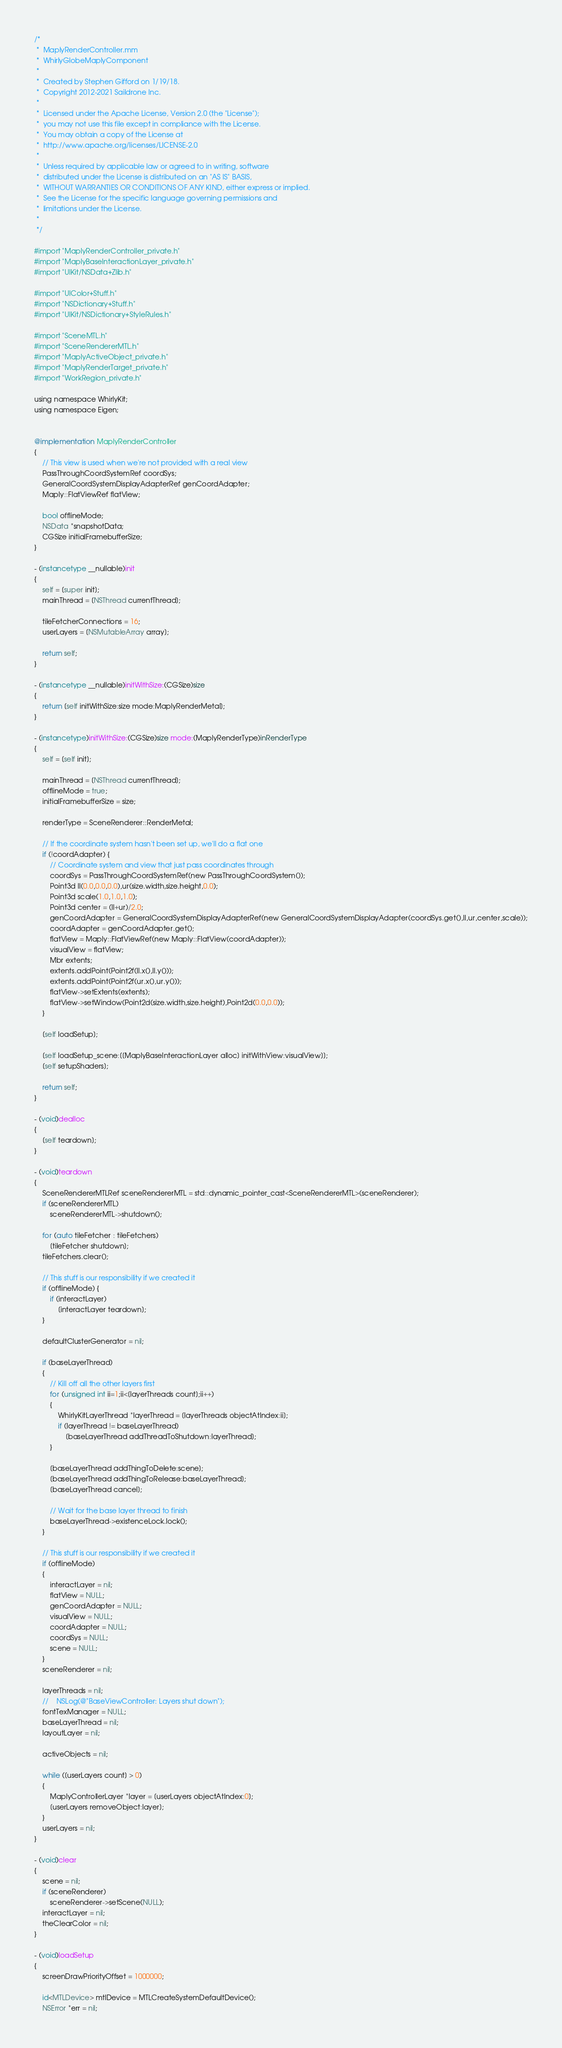<code> <loc_0><loc_0><loc_500><loc_500><_ObjectiveC_>/*
 *  MaplyRenderController.mm
 *  WhirlyGlobeMaplyComponent
 *
 *  Created by Stephen Gifford on 1/19/18.
 *  Copyright 2012-2021 Saildrone Inc.
 *
 *  Licensed under the Apache License, Version 2.0 (the "License");
 *  you may not use this file except in compliance with the License.
 *  You may obtain a copy of the License at
 *  http://www.apache.org/licenses/LICENSE-2.0
 *
 *  Unless required by applicable law or agreed to in writing, software
 *  distributed under the License is distributed on an "AS IS" BASIS,
 *  WITHOUT WARRANTIES OR CONDITIONS OF ANY KIND, either express or implied.
 *  See the License for the specific language governing permissions and
 *  limitations under the License.
 *
 */

#import "MaplyRenderController_private.h"
#import "MaplyBaseInteractionLayer_private.h"
#import "UIKit/NSData+Zlib.h"

#import "UIColor+Stuff.h"
#import "NSDictionary+Stuff.h"
#import "UIKit/NSDictionary+StyleRules.h"

#import "SceneMTL.h"
#import "SceneRendererMTL.h"
#import "MaplyActiveObject_private.h"
#import "MaplyRenderTarget_private.h"
#import "WorkRegion_private.h"

using namespace WhirlyKit;
using namespace Eigen;


@implementation MaplyRenderController
{
    // This view is used when we're not provided with a real view
    PassThroughCoordSystemRef coordSys;
    GeneralCoordSystemDisplayAdapterRef genCoordAdapter;
    Maply::FlatViewRef flatView;

    bool offlineMode;
    NSData *snapshotData;
    CGSize initialFramebufferSize;
}

- (instancetype __nullable)init
{
    self = [super init];
    mainThread = [NSThread currentThread];

    tileFetcherConnections = 16;
    userLayers = [NSMutableArray array];

    return self;
}

- (instancetype __nullable)initWithSize:(CGSize)size
{
    return [self initWithSize:size mode:MaplyRenderMetal];
}

- (instancetype)initWithSize:(CGSize)size mode:(MaplyRenderType)inRenderType
{
    self = [self init];

    mainThread = [NSThread currentThread];
    offlineMode = true;
    initialFramebufferSize = size;
    
    renderType = SceneRenderer::RenderMetal;
    
    // If the coordinate system hasn't been set up, we'll do a flat one
    if (!coordAdapter) {
        // Coordinate system and view that just pass coordinates through
        coordSys = PassThroughCoordSystemRef(new PassThroughCoordSystem());
        Point3d ll(0.0,0.0,0.0),ur(size.width,size.height,0.0);
        Point3d scale(1.0,1.0,1.0);
        Point3d center = (ll+ur)/2.0;
        genCoordAdapter = GeneralCoordSystemDisplayAdapterRef(new GeneralCoordSystemDisplayAdapter(coordSys.get(),ll,ur,center,scale));
        coordAdapter = genCoordAdapter.get();
        flatView = Maply::FlatViewRef(new Maply::FlatView(coordAdapter));
        visualView = flatView;
        Mbr extents;
        extents.addPoint(Point2f(ll.x(),ll.y()));
        extents.addPoint(Point2f(ur.x(),ur.y()));
        flatView->setExtents(extents);
        flatView->setWindow(Point2d(size.width,size.height),Point2d(0.0,0.0));
    }
    
    [self loadSetup];
    
    [self loadSetup_scene:[[MaplyBaseInteractionLayer alloc] initWithView:visualView]];
    [self setupShaders];
        
    return self;
}

- (void)dealloc
{
    [self teardown];
}

- (void)teardown
{
    SceneRendererMTLRef sceneRendererMTL = std::dynamic_pointer_cast<SceneRendererMTL>(sceneRenderer);
    if (sceneRendererMTL)
        sceneRendererMTL->shutdown();
    
    for (auto tileFetcher : tileFetchers)
        [tileFetcher shutdown];
    tileFetchers.clear();
    
    // This stuff is our responsibility if we created it
    if (offlineMode) {
        if (interactLayer)
            [interactLayer teardown];
    }
    
    defaultClusterGenerator = nil;

    if (baseLayerThread)
    {
        // Kill off all the other layers first
        for (unsigned int ii=1;ii<[layerThreads count];ii++)
        {
            WhirlyKitLayerThread *layerThread = [layerThreads objectAtIndex:ii];
            if (layerThread != baseLayerThread)
                [baseLayerThread addThreadToShutdown:layerThread];
        }

        [baseLayerThread addThingToDelete:scene];
        [baseLayerThread addThingToRelease:baseLayerThread];
        [baseLayerThread cancel];
        
        // Wait for the base layer thread to finish
        baseLayerThread->existenceLock.lock();
    }

    // This stuff is our responsibility if we created it
    if (offlineMode)
    {
        interactLayer = nil;
        flatView = NULL;
        genCoordAdapter = NULL;
        visualView = NULL;
        coordAdapter = NULL;
        coordSys = NULL;
        scene = NULL;
    }
    sceneRenderer = nil;
    
    layerThreads = nil;
    //    NSLog(@"BaseViewController: Layers shut down");
    fontTexManager = NULL;
    baseLayerThread = nil;
    layoutLayer = nil;

    activeObjects = nil;
    
    while ([userLayers count] > 0)
    {
        MaplyControllerLayer *layer = [userLayers objectAtIndex:0];
        [userLayers removeObject:layer];
    }
    userLayers = nil;
}

- (void)clear
{
    scene = nil;
    if (sceneRenderer)
        sceneRenderer->setScene(NULL);
    interactLayer = nil;
    theClearColor = nil;
}

- (void)loadSetup
{
    screenDrawPriorityOffset = 1000000;
    
    id<MTLDevice> mtlDevice = MTLCreateSystemDefaultDevice();
    NSError *err = nil;</code> 